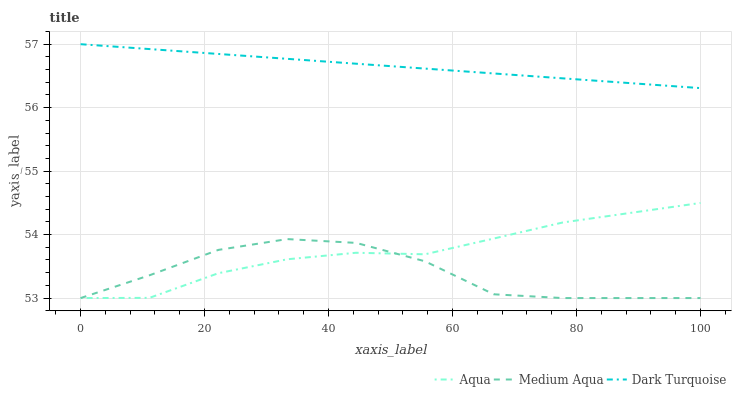Does Medium Aqua have the minimum area under the curve?
Answer yes or no. Yes. Does Dark Turquoise have the maximum area under the curve?
Answer yes or no. Yes. Does Aqua have the minimum area under the curve?
Answer yes or no. No. Does Aqua have the maximum area under the curve?
Answer yes or no. No. Is Dark Turquoise the smoothest?
Answer yes or no. Yes. Is Medium Aqua the roughest?
Answer yes or no. Yes. Is Aqua the smoothest?
Answer yes or no. No. Is Aqua the roughest?
Answer yes or no. No. Does Medium Aqua have the lowest value?
Answer yes or no. Yes. Does Dark Turquoise have the lowest value?
Answer yes or no. No. Does Dark Turquoise have the highest value?
Answer yes or no. Yes. Does Aqua have the highest value?
Answer yes or no. No. Is Medium Aqua less than Dark Turquoise?
Answer yes or no. Yes. Is Dark Turquoise greater than Aqua?
Answer yes or no. Yes. Does Medium Aqua intersect Aqua?
Answer yes or no. Yes. Is Medium Aqua less than Aqua?
Answer yes or no. No. Is Medium Aqua greater than Aqua?
Answer yes or no. No. Does Medium Aqua intersect Dark Turquoise?
Answer yes or no. No. 